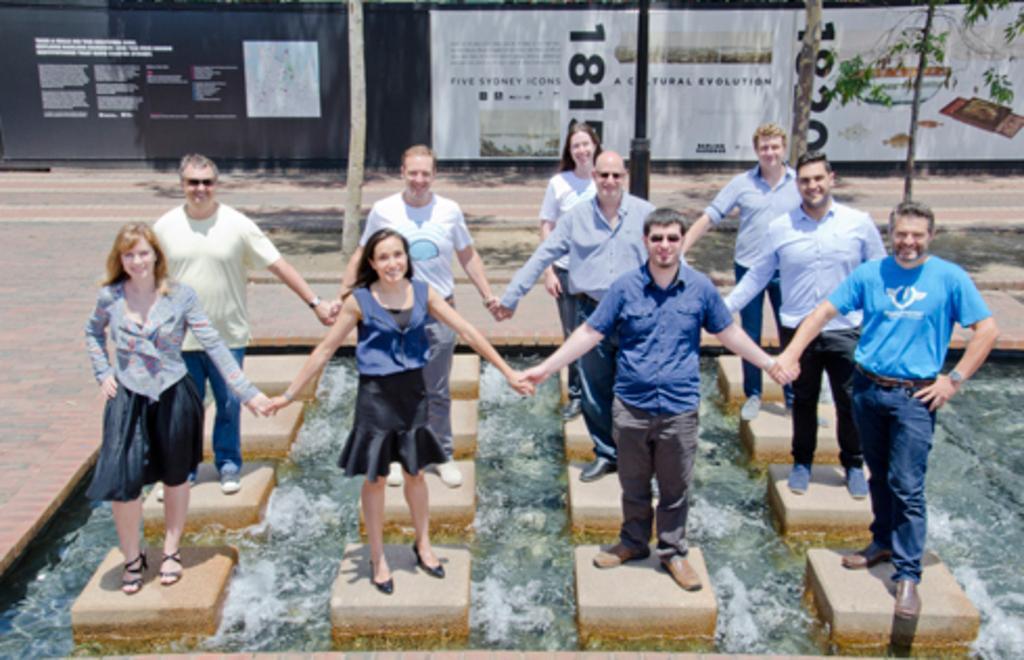How would you summarize this image in a sentence or two? In this image we can see men and women are holding their hands and standing on the square shape platforms. In between the platforms water is present. Background of the image banners and poles are present. 